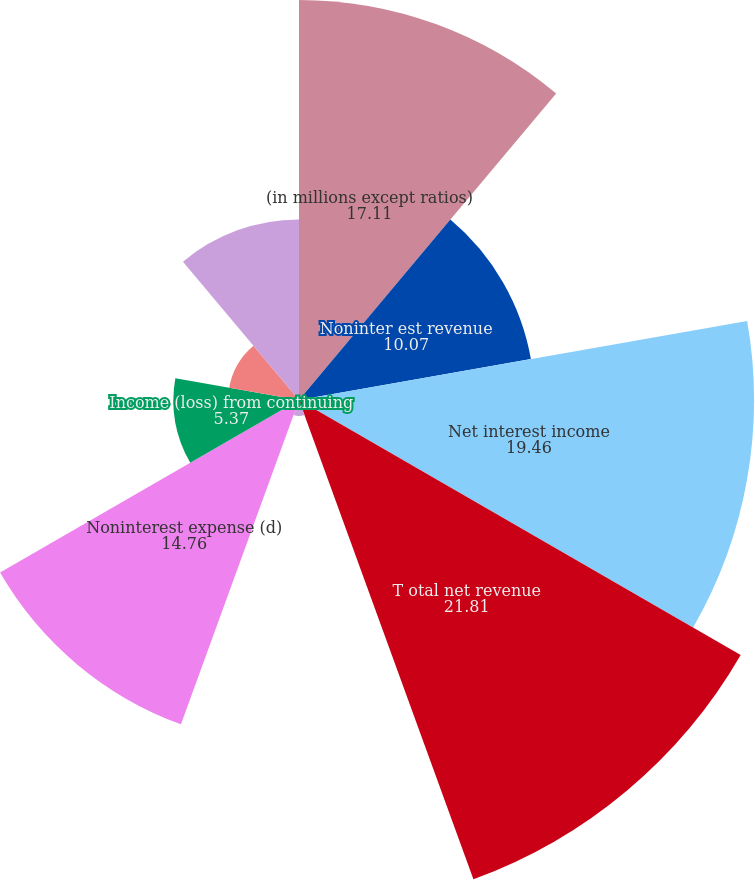Convert chart to OTSL. <chart><loc_0><loc_0><loc_500><loc_500><pie_chart><fcel>(in millions except ratios)<fcel>Noninter est revenue<fcel>Net interest income<fcel>T otal net revenue<fcel>Provision for credit losses<fcel>Noninterest expense (d)<fcel>Income (loss) from continuing<fcel>Income tax expense (benefit)<fcel>Net income (loss)<nl><fcel>17.11%<fcel>10.07%<fcel>19.46%<fcel>21.81%<fcel>0.68%<fcel>14.76%<fcel>5.37%<fcel>3.03%<fcel>7.72%<nl></chart> 